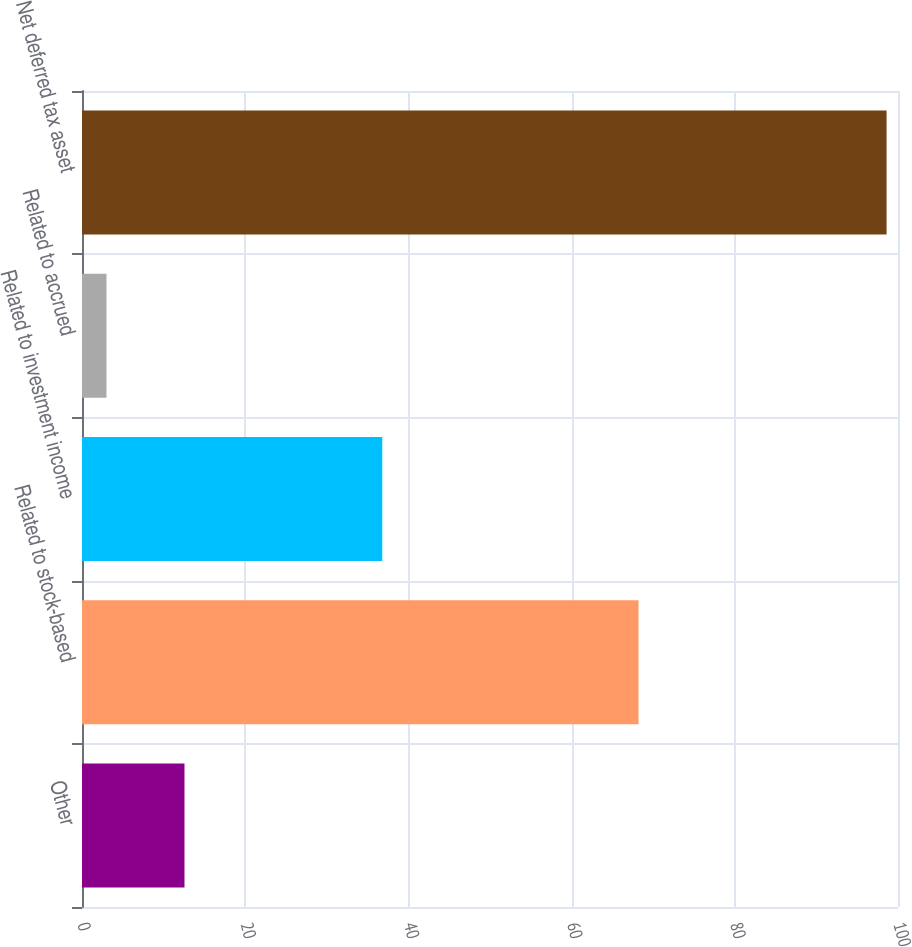<chart> <loc_0><loc_0><loc_500><loc_500><bar_chart><fcel>Other<fcel>Related to stock-based<fcel>Related to investment income<fcel>Related to accrued<fcel>Net deferred tax asset<nl><fcel>12.56<fcel>68.2<fcel>36.8<fcel>3<fcel>98.6<nl></chart> 